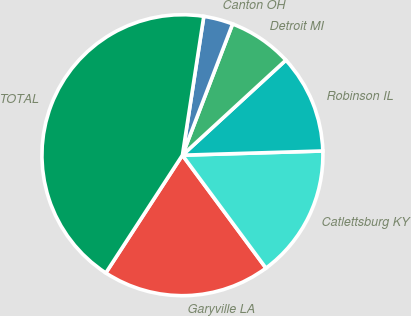Convert chart to OTSL. <chart><loc_0><loc_0><loc_500><loc_500><pie_chart><fcel>Garyville LA<fcel>Catlettsburg KY<fcel>Robinson IL<fcel>Detroit MI<fcel>Canton OH<fcel>TOTAL<nl><fcel>19.32%<fcel>15.34%<fcel>11.35%<fcel>7.36%<fcel>3.38%<fcel>43.25%<nl></chart> 